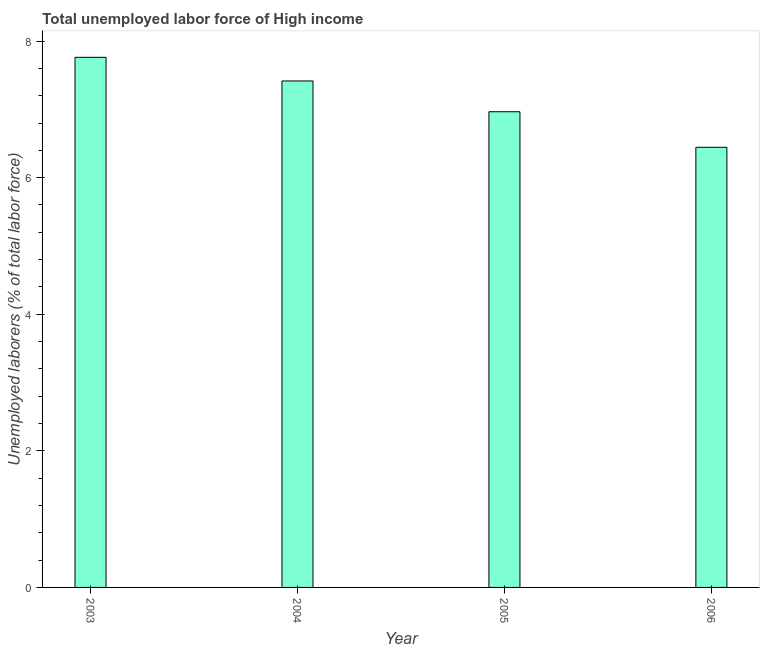Does the graph contain any zero values?
Give a very brief answer. No. What is the title of the graph?
Make the answer very short. Total unemployed labor force of High income. What is the label or title of the X-axis?
Offer a terse response. Year. What is the label or title of the Y-axis?
Provide a short and direct response. Unemployed laborers (% of total labor force). What is the total unemployed labour force in 2004?
Provide a short and direct response. 7.42. Across all years, what is the maximum total unemployed labour force?
Keep it short and to the point. 7.76. Across all years, what is the minimum total unemployed labour force?
Provide a short and direct response. 6.45. In which year was the total unemployed labour force minimum?
Make the answer very short. 2006. What is the sum of the total unemployed labour force?
Keep it short and to the point. 28.59. What is the difference between the total unemployed labour force in 2005 and 2006?
Your answer should be compact. 0.52. What is the average total unemployed labour force per year?
Provide a succinct answer. 7.15. What is the median total unemployed labour force?
Provide a succinct answer. 7.19. In how many years, is the total unemployed labour force greater than 2 %?
Ensure brevity in your answer.  4. Do a majority of the years between 2003 and 2006 (inclusive) have total unemployed labour force greater than 5.2 %?
Ensure brevity in your answer.  Yes. What is the ratio of the total unemployed labour force in 2003 to that in 2005?
Your answer should be compact. 1.11. What is the difference between the highest and the second highest total unemployed labour force?
Provide a short and direct response. 0.35. What is the difference between the highest and the lowest total unemployed labour force?
Your answer should be very brief. 1.32. How many bars are there?
Your answer should be very brief. 4. Are all the bars in the graph horizontal?
Offer a terse response. No. How many years are there in the graph?
Make the answer very short. 4. What is the difference between two consecutive major ticks on the Y-axis?
Make the answer very short. 2. Are the values on the major ticks of Y-axis written in scientific E-notation?
Provide a short and direct response. No. What is the Unemployed laborers (% of total labor force) in 2003?
Keep it short and to the point. 7.76. What is the Unemployed laborers (% of total labor force) of 2004?
Make the answer very short. 7.42. What is the Unemployed laborers (% of total labor force) in 2005?
Your answer should be compact. 6.97. What is the Unemployed laborers (% of total labor force) in 2006?
Your answer should be compact. 6.45. What is the difference between the Unemployed laborers (% of total labor force) in 2003 and 2004?
Keep it short and to the point. 0.35. What is the difference between the Unemployed laborers (% of total labor force) in 2003 and 2005?
Provide a succinct answer. 0.8. What is the difference between the Unemployed laborers (% of total labor force) in 2003 and 2006?
Your response must be concise. 1.32. What is the difference between the Unemployed laborers (% of total labor force) in 2004 and 2005?
Your answer should be very brief. 0.45. What is the difference between the Unemployed laborers (% of total labor force) in 2004 and 2006?
Offer a terse response. 0.97. What is the difference between the Unemployed laborers (% of total labor force) in 2005 and 2006?
Keep it short and to the point. 0.52. What is the ratio of the Unemployed laborers (% of total labor force) in 2003 to that in 2004?
Ensure brevity in your answer.  1.05. What is the ratio of the Unemployed laborers (% of total labor force) in 2003 to that in 2005?
Provide a succinct answer. 1.11. What is the ratio of the Unemployed laborers (% of total labor force) in 2003 to that in 2006?
Offer a very short reply. 1.2. What is the ratio of the Unemployed laborers (% of total labor force) in 2004 to that in 2005?
Keep it short and to the point. 1.06. What is the ratio of the Unemployed laborers (% of total labor force) in 2004 to that in 2006?
Provide a short and direct response. 1.15. What is the ratio of the Unemployed laborers (% of total labor force) in 2005 to that in 2006?
Keep it short and to the point. 1.08. 